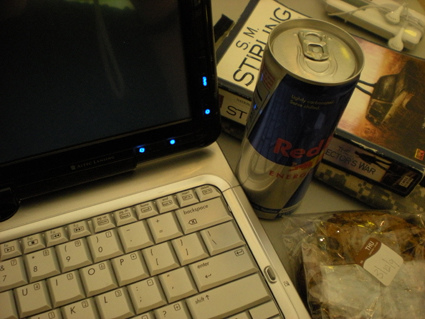Identify the text contained in this image. S M. Red ST L U 